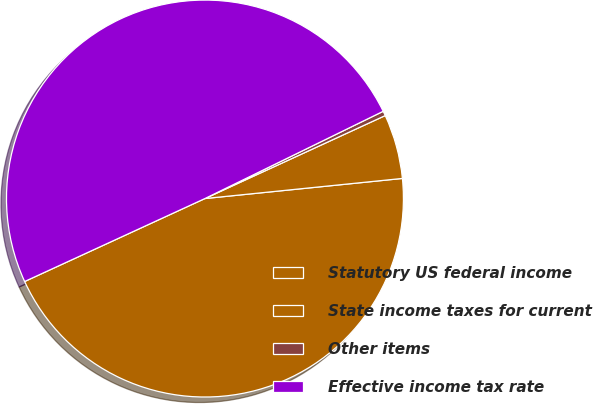<chart> <loc_0><loc_0><loc_500><loc_500><pie_chart><fcel>Statutory US federal income<fcel>State income taxes for current<fcel>Other items<fcel>Effective income tax rate<nl><fcel>44.75%<fcel>5.25%<fcel>0.38%<fcel>49.62%<nl></chart> 